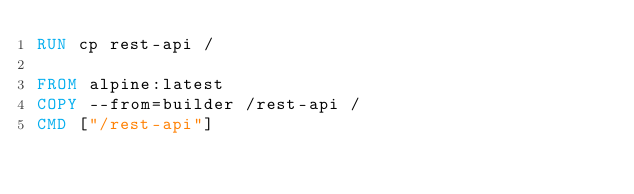Convert code to text. <code><loc_0><loc_0><loc_500><loc_500><_Dockerfile_>RUN cp rest-api /

FROM alpine:latest
COPY --from=builder /rest-api /
CMD ["/rest-api"]
</code> 